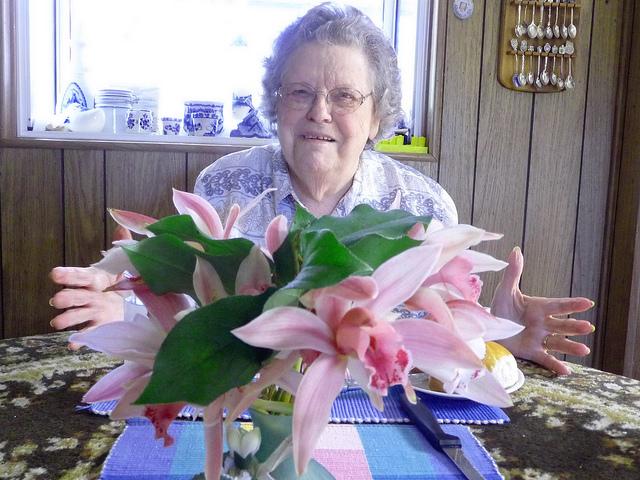What is hanging on the wall?
Write a very short answer. Spoons. What is on the window sill?
Quick response, please. Dishes. What color are the flowers?
Be succinct. Pink. 